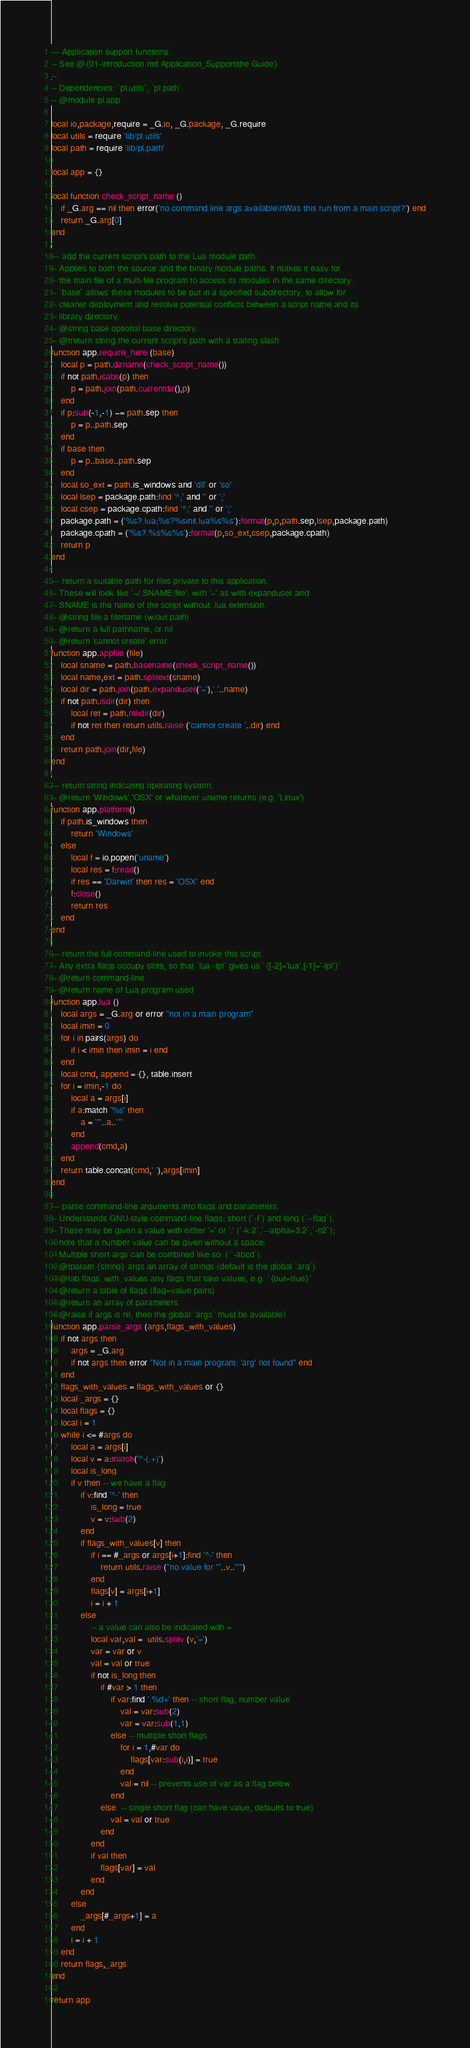<code> <loc_0><loc_0><loc_500><loc_500><_Lua_>--- Application support functions.
-- See @{01-introduction.md.Application_Support|the Guide}
--
-- Dependencies: `pl.utils`, `pl.path`
-- @module pl.app

local io,package,require = _G.io, _G.package, _G.require
local utils = require 'lib/pl.utils'
local path = require 'lib/pl.path'

local app = {}

local function check_script_name ()
    if _G.arg == nil then error('no command line args available\nWas this run from a main script?') end
    return _G.arg[0]
end

--- add the current script's path to the Lua module path.
-- Applies to both the source and the binary module paths. It makes it easy for
-- the main file of a multi-file program to access its modules in the same directory.
-- `base` allows these modules to be put in a specified subdirectory, to allow for
-- cleaner deployment and resolve potential conflicts between a script name and its
-- library directory.
-- @string base optional base directory.
-- @treturn string the current script's path with a trailing slash
function app.require_here (base)
    local p = path.dirname(check_script_name())
    if not path.isabs(p) then
        p = path.join(path.currentdir(),p)
    end
    if p:sub(-1,-1) ~= path.sep then
        p = p..path.sep
    end
    if base then
        p = p..base..path.sep
    end
    local so_ext = path.is_windows and 'dll' or 'so'
    local lsep = package.path:find '^;' and '' or ';'
    local csep = package.cpath:find '^;' and '' or ';'
    package.path = ('%s?.lua;%s?%sinit.lua%s%s'):format(p,p,path.sep,lsep,package.path)
    package.cpath = ('%s?.%s%s%s'):format(p,so_ext,csep,package.cpath)
    return p
end

--- return a suitable path for files private to this application.
-- These will look like '~/.SNAME/file', with '~' as with expanduser and
-- SNAME is the name of the script without .lua extension.
-- @string file a filename (w/out path)
-- @return a full pathname, or nil
-- @return 'cannot create' error
function app.appfile (file)
    local sname = path.basename(check_script_name())
    local name,ext = path.splitext(sname)
    local dir = path.join(path.expanduser('~'),'.'..name)
    if not path.isdir(dir) then
        local ret = path.mkdir(dir)
        if not ret then return utils.raise ('cannot create '..dir) end
    end
    return path.join(dir,file)
end

--- return string indicating operating system.
-- @return 'Windows','OSX' or whatever uname returns (e.g. 'Linux')
function app.platform()
    if path.is_windows then
        return 'Windows'
    else
        local f = io.popen('uname')
        local res = f:read()
        if res == 'Darwin' then res = 'OSX' end
        f:close()
        return res
    end
end

--- return the full command-line used to invoke this script.
-- Any extra flags occupy slots, so that `lua -lpl` gives us `{[-2]='lua',[-1]='-lpl'}`
-- @return command-line
-- @return name of Lua program used
function app.lua ()
    local args = _G.arg or error "not in a main program"
    local imin = 0
    for i in pairs(args) do
        if i < imin then imin = i end
    end
    local cmd, append = {}, table.insert
    for i = imin,-1 do
        local a = args[i]
        if a:match '%s' then
            a = '"'..a..'"'
        end
        append(cmd,a)
    end
    return table.concat(cmd,' '),args[imin]
end

--- parse command-line arguments into flags and parameters.
-- Understands GNU-style command-line flags; short (`-f`) and long (`--flag`).
-- These may be given a value with either '=' or ':' (`-k:2`,`--alpha=3.2`,`-n2`);
-- note that a number value can be given without a space.
-- Multiple short args can be combined like so: ( `-abcd`).
-- @tparam {string} args an array of strings (default is the global `arg`)
-- @tab flags_with_values any flags that take values, e.g. `{out=true}`
-- @return a table of flags (flag=value pairs)
-- @return an array of parameters
-- @raise if args is nil, then the global `args` must be available!
function app.parse_args (args,flags_with_values)
    if not args then
        args = _G.arg
        if not args then error "Not in a main program: 'arg' not found" end
    end
    flags_with_values = flags_with_values or {}
    local _args = {}
    local flags = {}
    local i = 1
    while i <= #args do
        local a = args[i]
        local v = a:match('^-(.+)')
        local is_long
        if v then -- we have a flag
            if v:find '^-' then
                is_long = true
                v = v:sub(2)
            end
            if flags_with_values[v] then
                if i == #_args or args[i+1]:find '^-' then
                    return utils.raise ("no value for '"..v.."'")
                end
                flags[v] = args[i+1]
                i = i + 1
            else
                -- a value can also be indicated with =
                local var,val =  utils.splitv (v,'=')
                var = var or v
                val = val or true
                if not is_long then
                    if #var > 1 then
                        if var:find '.%d+' then -- short flag, number value
                            val = var:sub(2)
                            var = var:sub(1,1)
                        else -- multiple short flags
                            for i = 1,#var do
                                flags[var:sub(i,i)] = true
                            end
                            val = nil -- prevents use of var as a flag below
                        end
                    else  -- single short flag (can have value, defaults to true)
                        val = val or true
                    end
                end
                if val then
                    flags[var] = val
                end
            end
        else
            _args[#_args+1] = a
        end
        i = i + 1
    end
    return flags,_args
end

return app
</code> 